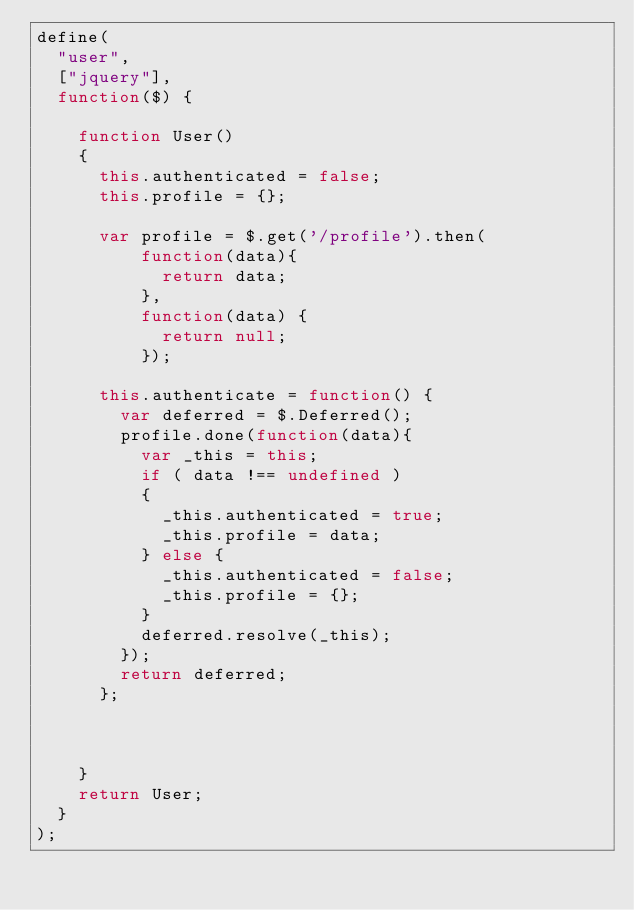Convert code to text. <code><loc_0><loc_0><loc_500><loc_500><_JavaScript_>define(
  "user",
  ["jquery"],
  function($) {

    function User()
    {
      this.authenticated = false;
      this.profile = {};

      var profile = $.get('/profile').then(
          function(data){
            return data;
          },
          function(data) {
            return null;
          });

      this.authenticate = function() {
        var deferred = $.Deferred();
        profile.done(function(data){
          var _this = this;
          if ( data !== undefined )
          {
            _this.authenticated = true;
            _this.profile = data;
          } else {
            _this.authenticated = false;
            _this.profile = {};
          }
          deferred.resolve(_this);
        });
        return deferred;
      };



    }
    return User;
  }
);
</code> 